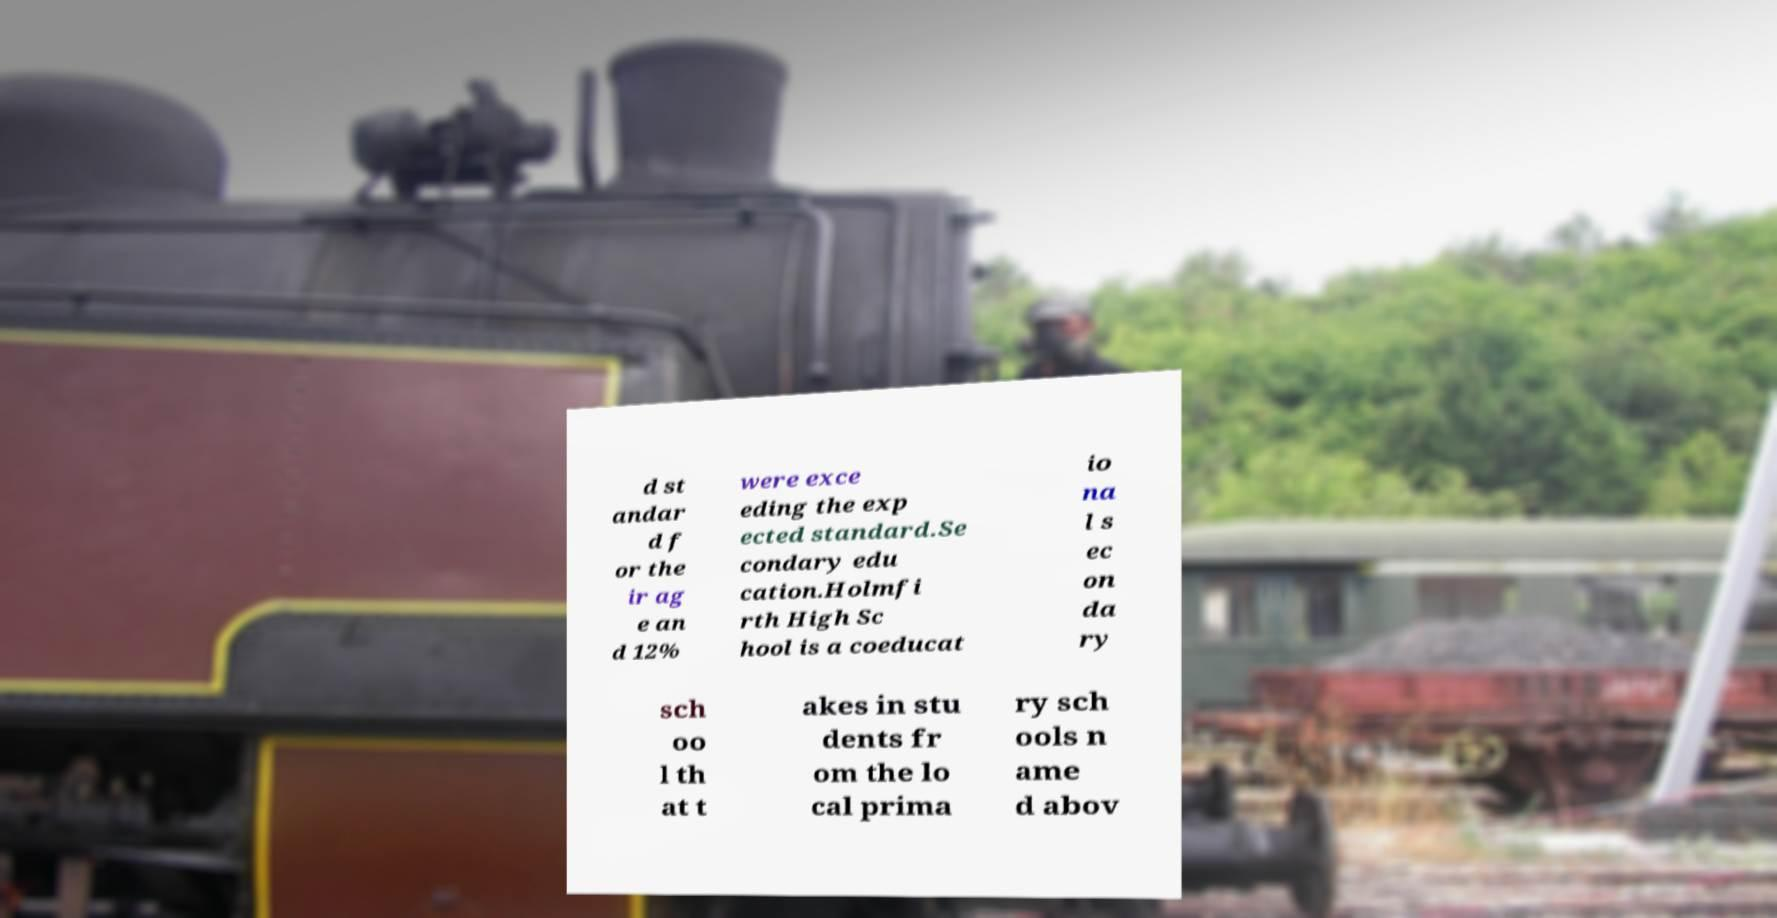Please read and relay the text visible in this image. What does it say? d st andar d f or the ir ag e an d 12% were exce eding the exp ected standard.Se condary edu cation.Holmfi rth High Sc hool is a coeducat io na l s ec on da ry sch oo l th at t akes in stu dents fr om the lo cal prima ry sch ools n ame d abov 